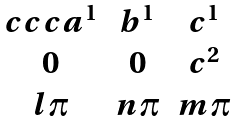Convert formula to latex. <formula><loc_0><loc_0><loc_500><loc_500>\begin{matrix} { c c c } a ^ { 1 } & b ^ { 1 } & c ^ { 1 } \\ 0 & 0 & c ^ { 2 } \\ l \pi & n \pi & m \pi \end{matrix}</formula> 